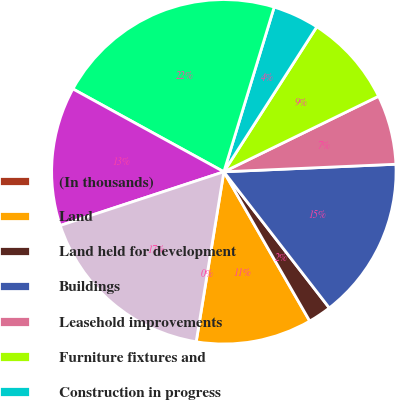<chart> <loc_0><loc_0><loc_500><loc_500><pie_chart><fcel>(In thousands)<fcel>Land<fcel>Land held for development<fcel>Buildings<fcel>Leasehold improvements<fcel>Furniture fixtures and<fcel>Construction in progress<fcel>Total property and equipment<fcel>Less accumulated depreciation<fcel>Property and equipment net<nl><fcel>0.01%<fcel>10.87%<fcel>2.18%<fcel>15.21%<fcel>6.53%<fcel>8.7%<fcel>4.35%<fcel>21.73%<fcel>13.04%<fcel>17.38%<nl></chart> 